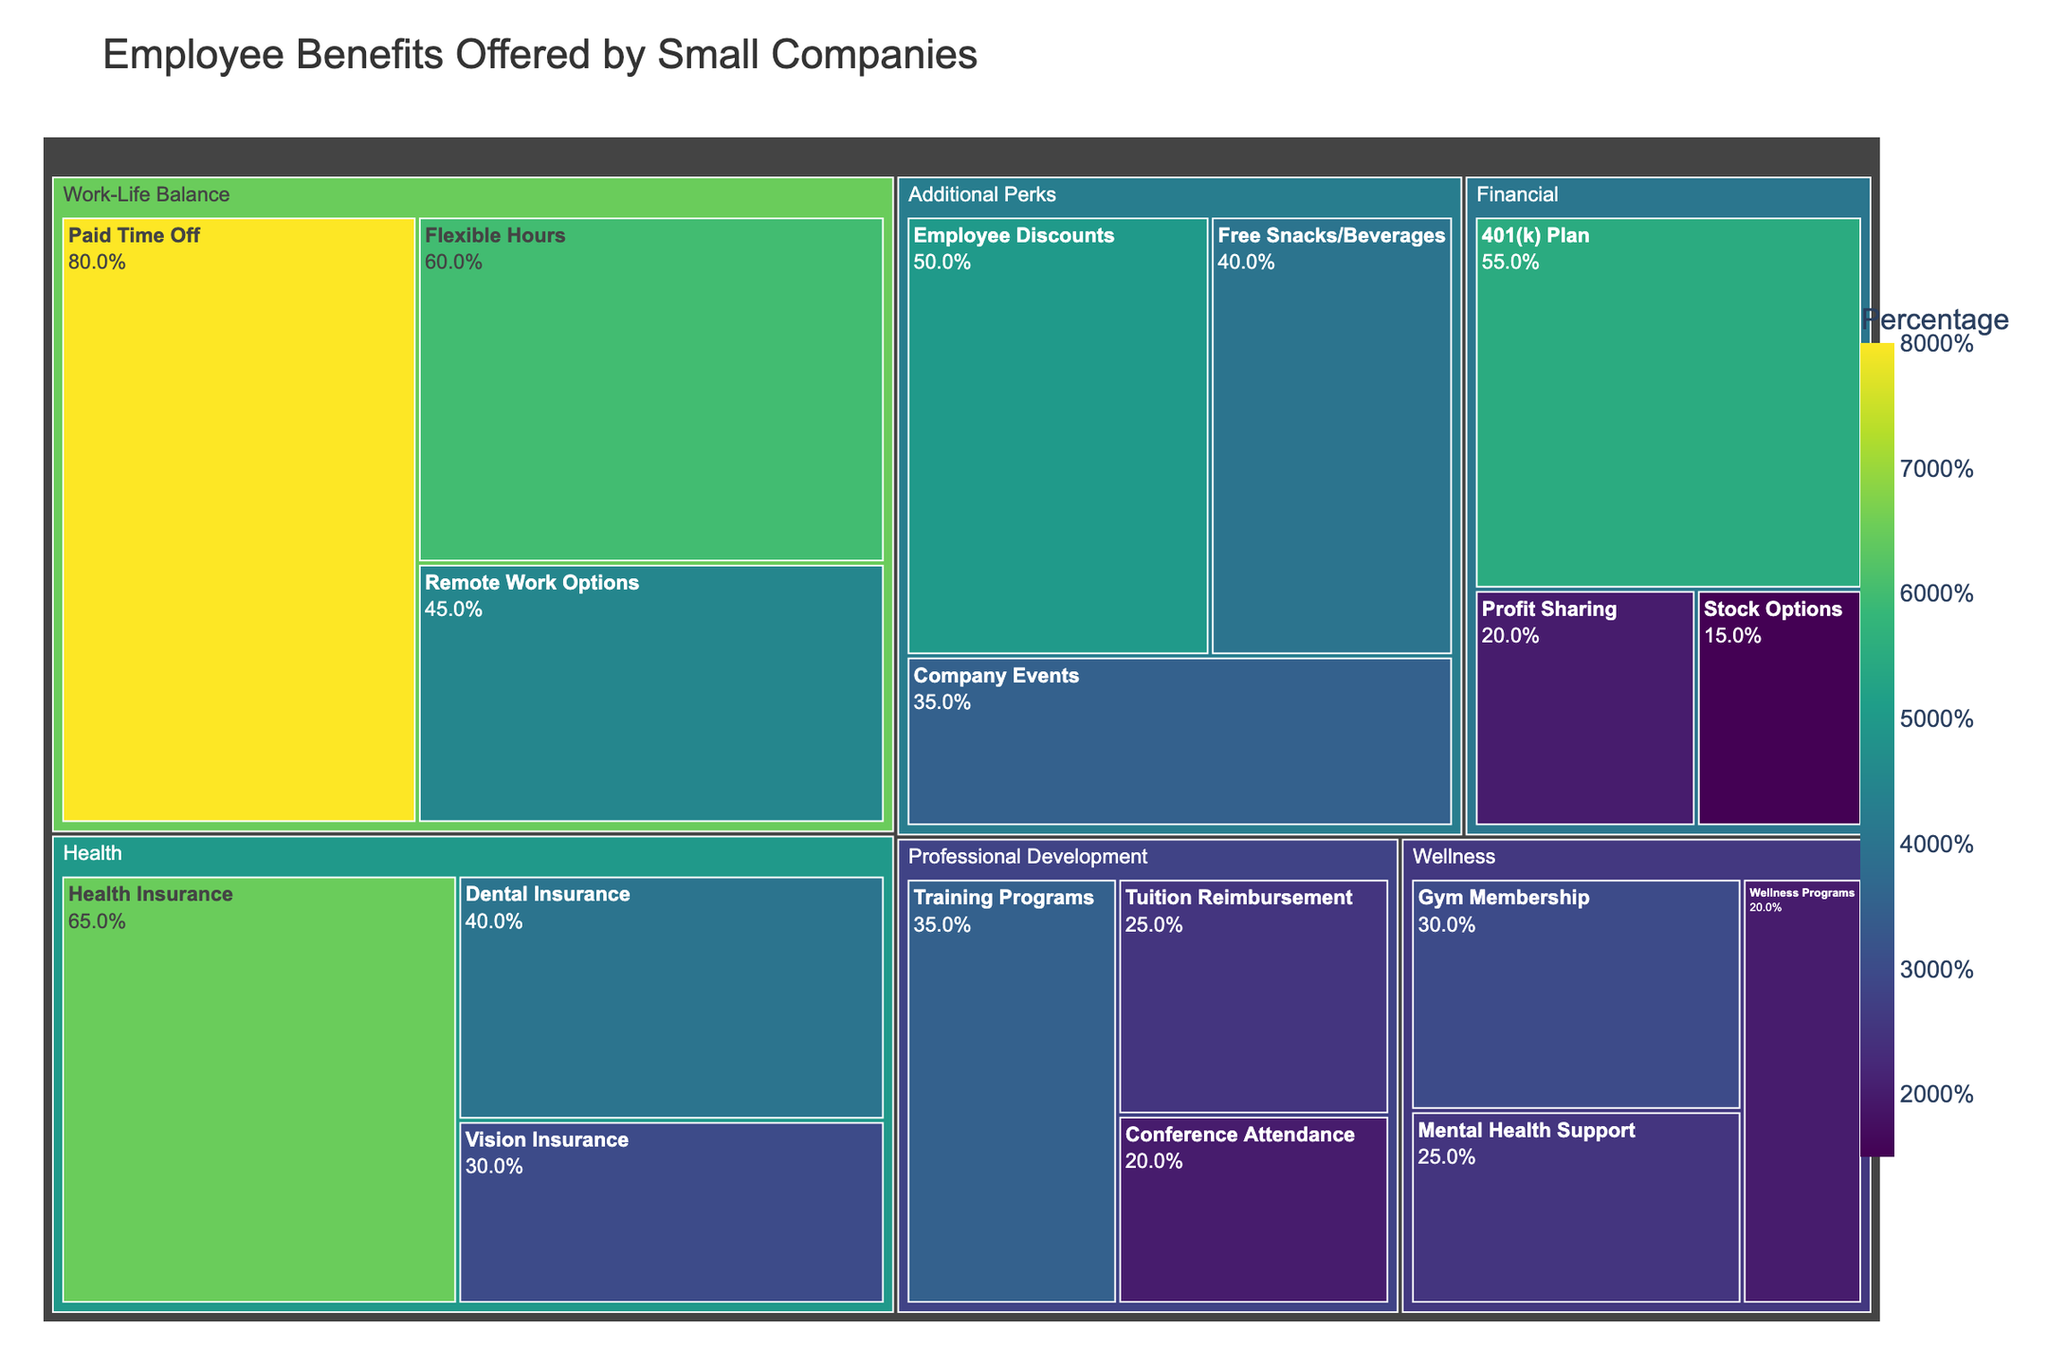What's the title of the treemap? The title of the treemap is usually placed at the top and gives an overview of what the visualization is about. In this case, the title is "Employee Benefits Offered by Small Companies."
Answer: Employee Benefits Offered by Small Companies Which benefit has the highest percentage offered by small companies? The benefit with the highest percentage can be identified by looking at the largest section in the treemap, which is "Paid Time Off" under the "Work-Life Balance" category with 80%.
Answer: Paid Time Off What percentage of small companies offer dental insurance? Locate the "Dental Insurance" benefit within the "Health" category in the treemap, which shows it is offered by 40% of small companies.
Answer: 40% Which category contains the largest number of different benefits? By counting the different benefits within each category on the treemap: 
- Health: 3 benefits
- Financial: 3 benefits
- Work-Life Balance: 3 benefits
- Professional Development: 3 benefits
- Wellness: 3 benefits
- Additional Perks: 3 benefits
All categories contain an equal number of different benefits (3 each).
Answer: All categories (3 benefits each) What is the combined percentage of companies offering Health Insurance and Vision Insurance? The percentage of Health Insurance is 65% and Vision Insurance is 30%. Adding them together: 65 + 30 = 95%
Answer: 95% Are there more companies offering flexible hours or remote work options? Compare the percentages from the "Work-Life Balance" category. Flexible Hours is at 60% and Remote Work Options is at 45%, so more companies offer Flexible Hours.
Answer: Flexible Hours Which benefit category falls under 'Training Programs'? "Training Programs" is located within the "Professional Development" category as seen on the treemap.
Answer: Professional Development What is the lowest percentage benefit offered by small companies? The smallest sections in the treemap represent benefits like "Stock Options," "Conference Attendance," and "Wellness Programs," all at 15% and 20% respectively.
Answer: Stock Options (15%) 